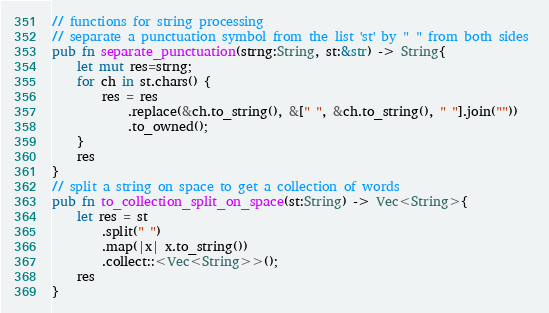<code> <loc_0><loc_0><loc_500><loc_500><_Rust_>// functions for string processing 
// separate a punctuation symbol from the list 'st' by " " from both sides 
pub fn separate_punctuation(strng:String, st:&str) -> String{
    let mut res=strng;
    for ch in st.chars() {
        res = res
            .replace(&ch.to_string(), &[" ", &ch.to_string(), " "].join(""))
            .to_owned();
    }
    res
}
// split a string on space to get a collection of words
pub fn to_collection_split_on_space(st:String) -> Vec<String>{
    let res = st
        .split(" ")
        .map(|x| x.to_string())
        .collect::<Vec<String>>();
    res
}

</code> 